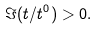Convert formula to latex. <formula><loc_0><loc_0><loc_500><loc_500>\Im ( t / t ^ { 0 } ) > 0 .</formula> 